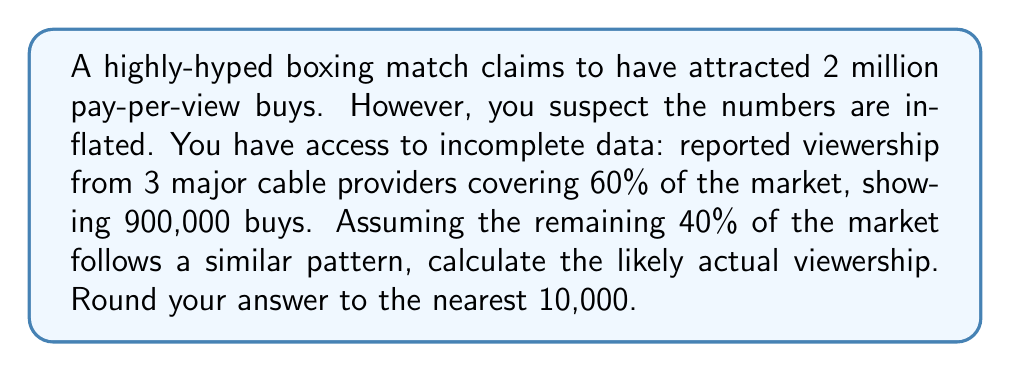Can you answer this question? Let's approach this step-by-step:

1) First, we need to understand what the given data represents:
   - 60% of the market reported 900,000 buys
   - We need to estimate the remaining 40% and add it to the known 60%

2) To find the viewership for 100% of the market, we can set up a proportion:
   
   $$\frac{900,000}{0.60} = \frac{x}{1}$$

   Where $x$ is the total viewership for 100% of the market.

3) Solve for $x$:
   
   $$x = \frac{900,000}{0.60} = 1,500,000$$

4) Round to the nearest 10,000:
   
   $$1,500,000 \approx 1,500,000$$

This result suggests that the actual viewership is likely closer to 1.5 million, rather than the claimed 2 million. This aligns with the cynical perspective on boxing hype, as the calculated number is 25% lower than the reported figure.
Answer: 1,500,000 viewers 